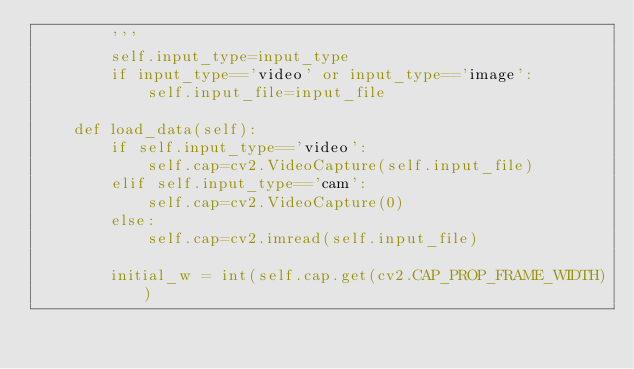Convert code to text. <code><loc_0><loc_0><loc_500><loc_500><_Python_>        '''
        self.input_type=input_type
        if input_type=='video' or input_type=='image':
            self.input_file=input_file
    
    def load_data(self):
        if self.input_type=='video':
            self.cap=cv2.VideoCapture(self.input_file)
        elif self.input_type=='cam':
            self.cap=cv2.VideoCapture(0)
        else:
            self.cap=cv2.imread(self.input_file)

        initial_w = int(self.cap.get(cv2.CAP_PROP_FRAME_WIDTH))</code> 